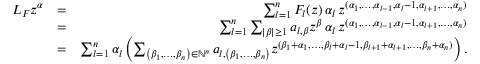<formula> <loc_0><loc_0><loc_500><loc_500>\begin{array} { r l r } { L _ { F } z ^ { \alpha } } & { = } & { \sum _ { l = 1 } ^ { n } F _ { l } ( z ) \, \alpha _ { l } \, z ^ { ( \alpha _ { 1 } , \dots , \alpha _ { l - 1 } , \alpha _ { l } - 1 , \alpha _ { l + 1 } , \dots , \alpha _ { n } ) } } \\ & { = } & { \sum _ { l = 1 } ^ { n } \sum _ { | \beta | \geq 1 } a _ { l , \beta } z ^ { \beta } \, \alpha _ { l } \, z ^ { ( \alpha _ { 1 } , \dots , \alpha _ { l - 1 } , \alpha _ { l } - 1 , \alpha _ { l + 1 } , \dots , \alpha _ { n } ) } } \\ & { = } & { \sum _ { l = 1 } ^ { n } \alpha _ { l } \left ( \sum _ { \left ( \beta _ { 1 } , \dots , \beta _ { n } \right ) \in \mathbb { N } ^ { n } } a _ { l , \left ( \beta _ { 1 } , \dots , \beta _ { n } \right ) } z ^ { ( \beta _ { 1 } + \alpha _ { 1 } , \dots , \beta _ { l } + \alpha _ { l } - 1 , \beta _ { l + 1 } + \alpha _ { l + 1 } , \dots , \beta _ { n } + \alpha _ { n } ) } \right ) . } \end{array}</formula> 